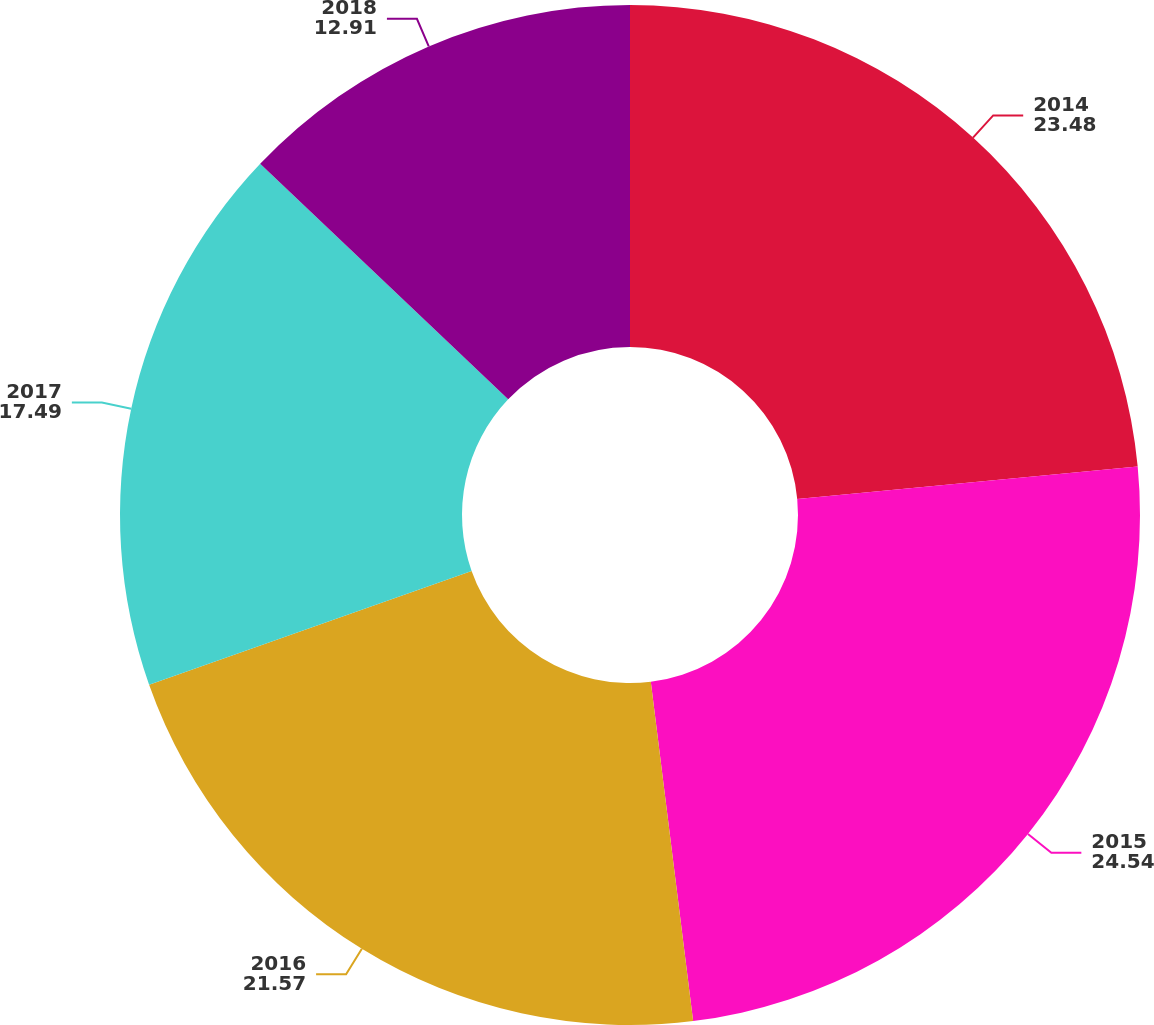Convert chart to OTSL. <chart><loc_0><loc_0><loc_500><loc_500><pie_chart><fcel>2014<fcel>2015<fcel>2016<fcel>2017<fcel>2018<nl><fcel>23.48%<fcel>24.54%<fcel>21.57%<fcel>17.49%<fcel>12.91%<nl></chart> 